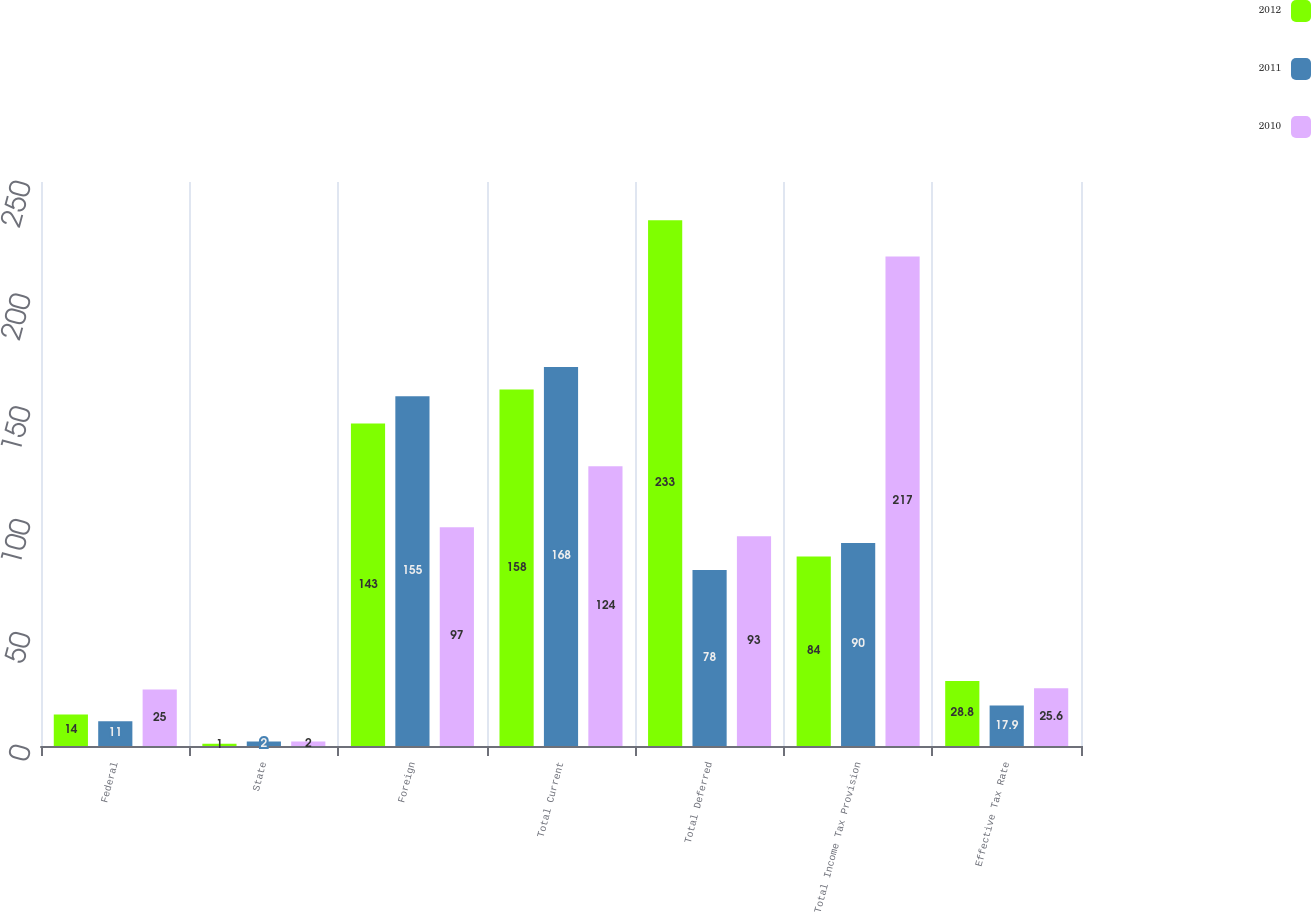<chart> <loc_0><loc_0><loc_500><loc_500><stacked_bar_chart><ecel><fcel>Federal<fcel>State<fcel>Foreign<fcel>Total Current<fcel>Total Deferred<fcel>Total Income Tax Provision<fcel>Effective Tax Rate<nl><fcel>2012<fcel>14<fcel>1<fcel>143<fcel>158<fcel>233<fcel>84<fcel>28.8<nl><fcel>2011<fcel>11<fcel>2<fcel>155<fcel>168<fcel>78<fcel>90<fcel>17.9<nl><fcel>2010<fcel>25<fcel>2<fcel>97<fcel>124<fcel>93<fcel>217<fcel>25.6<nl></chart> 